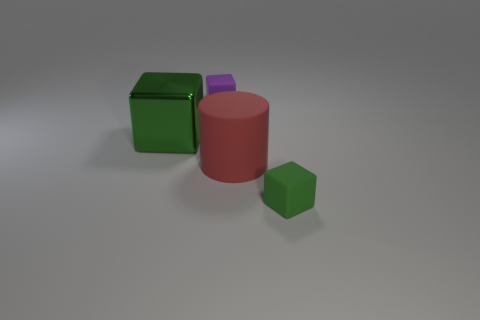Is the number of big objects behind the purple rubber cube the same as the number of blocks that are right of the large green metal object?
Provide a short and direct response. No. There is another metallic object that is the same shape as the small purple object; what size is it?
Ensure brevity in your answer.  Large. The rubber thing that is behind the big matte object has what shape?
Make the answer very short. Cube. Does the small object in front of the large red cylinder have the same material as the object that is on the left side of the purple block?
Keep it short and to the point. No. There is a shiny thing; what shape is it?
Provide a short and direct response. Cube. Are there the same number of green rubber cubes that are behind the small green matte thing and blocks?
Keep it short and to the point. No. The other cube that is the same color as the big block is what size?
Ensure brevity in your answer.  Small. Is there a small cyan object made of the same material as the big green object?
Ensure brevity in your answer.  No. There is a green thing that is to the left of the large red matte object; is its shape the same as the thing in front of the big red matte thing?
Give a very brief answer. Yes. Is there a green matte thing?
Provide a succinct answer. Yes. 